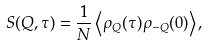<formula> <loc_0><loc_0><loc_500><loc_500>S ( { Q } , \tau ) = \frac { 1 } { N } \left \langle \rho _ { Q } ( \tau ) \rho _ { - Q } ( 0 ) \right \rangle ,</formula> 